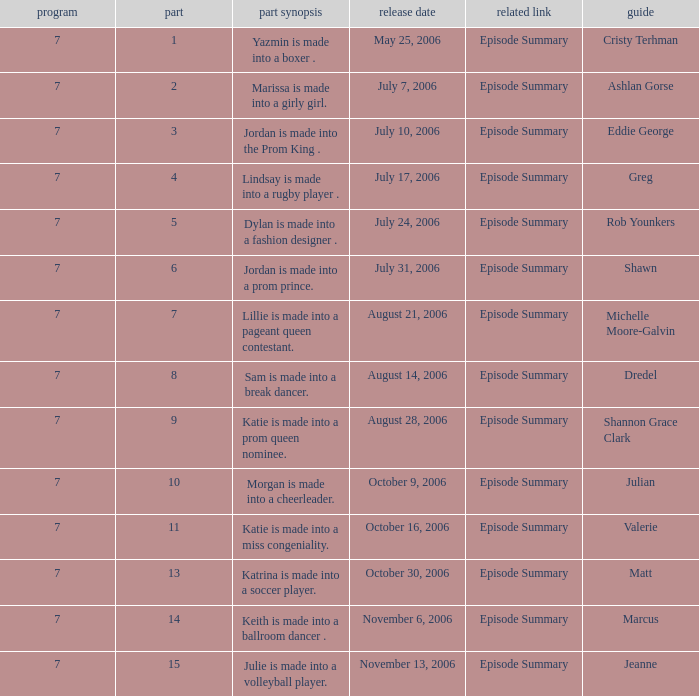What is the newest season? 7.0. 